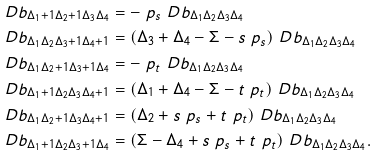<formula> <loc_0><loc_0><loc_500><loc_500>\ D b _ { \Delta _ { 1 } + 1 \Delta _ { 2 } + 1 \Delta _ { 3 } \Delta _ { 4 } } & = - \ p _ { s } \ D b _ { \Delta _ { 1 } \Delta _ { 2 } \Delta _ { 3 } \Delta _ { 4 } } \\ \ D b _ { \Delta _ { 1 } \Delta _ { 2 } \Delta _ { 3 } + 1 \Delta _ { 4 } + 1 } & = ( \Delta _ { 3 } + \Delta _ { 4 } - \Sigma - s \ p _ { s } ) \ D b _ { \Delta _ { 1 } \Delta _ { 2 } \Delta _ { 3 } \Delta _ { 4 } } \\ \ D b _ { \Delta _ { 1 } \Delta _ { 2 } + 1 \Delta _ { 3 } + 1 \Delta _ { 4 } } & = - \ p _ { t } \ D b _ { \Delta _ { 1 } \Delta _ { 2 } \Delta _ { 3 } \Delta _ { 4 } } \\ \ D b _ { \Delta _ { 1 } + 1 \Delta _ { 2 } \Delta _ { 3 } \Delta _ { 4 } + 1 } & = ( \Delta _ { 1 } + \Delta _ { 4 } - \Sigma - t \ p _ { t } ) \ D b _ { \Delta _ { 1 } \Delta _ { 2 } \Delta _ { 3 } \Delta _ { 4 } } \\ \ D b _ { \Delta _ { 1 } \Delta _ { 2 } + 1 \Delta _ { 3 } \Delta _ { 4 } + 1 } & = ( \Delta _ { 2 } + s \ p _ { s } + t \ p _ { t } ) \ D b _ { \Delta _ { 1 } \Delta _ { 2 } \Delta _ { 3 } \Delta _ { 4 } } \\ \ D b _ { \Delta _ { 1 } + 1 \Delta _ { 2 } \Delta _ { 3 } + 1 \Delta _ { 4 } } & = ( \Sigma - \Delta _ { 4 } + s \ p _ { s } + t \ p _ { t } ) \ D b _ { \Delta _ { 1 } \Delta _ { 2 } \Delta _ { 3 } \Delta _ { 4 } } .</formula> 